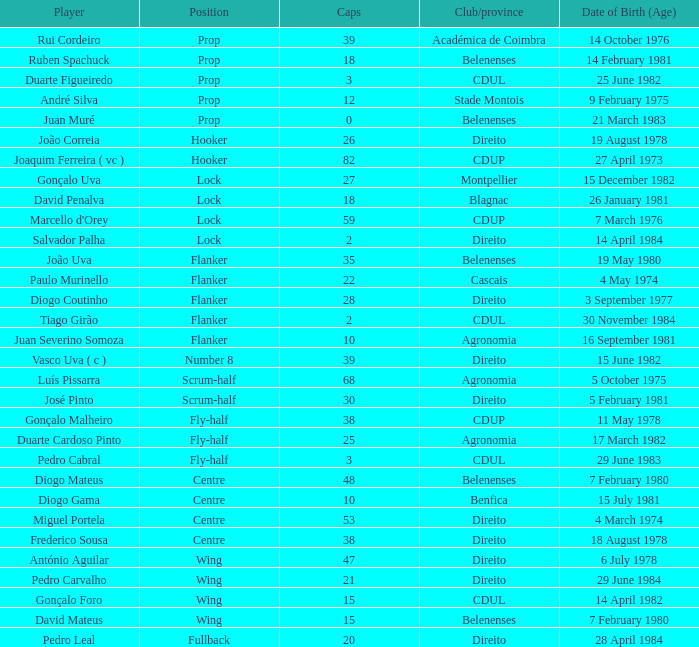How many caps have a Position of prop, and a Player of rui cordeiro? 1.0. 